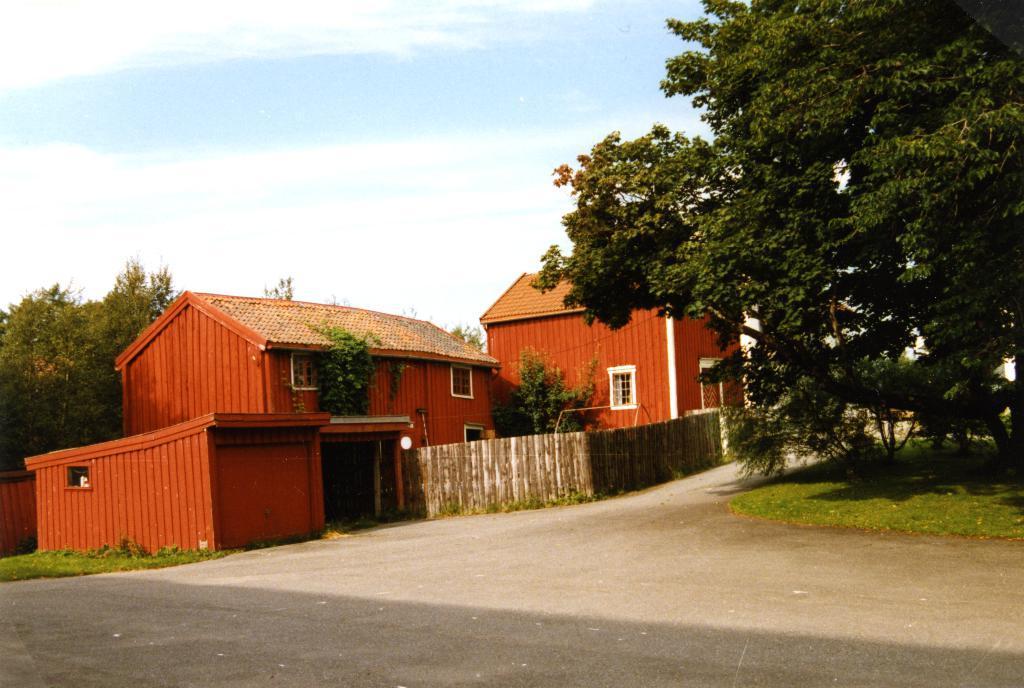Could you give a brief overview of what you see in this image? In this image we can see some houses, fence, trees and some other objects. At the bottom of the image there is the floor. On the right side of the image there are some trees and grass. In the background of the image there are trees and the sky. 